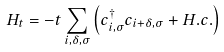Convert formula to latex. <formula><loc_0><loc_0><loc_500><loc_500>H _ { t } = - t \sum _ { i , \delta , \sigma } \left ( c ^ { \dagger } _ { i , \sigma } c _ { i + \delta , \sigma } + H . c . \right )</formula> 